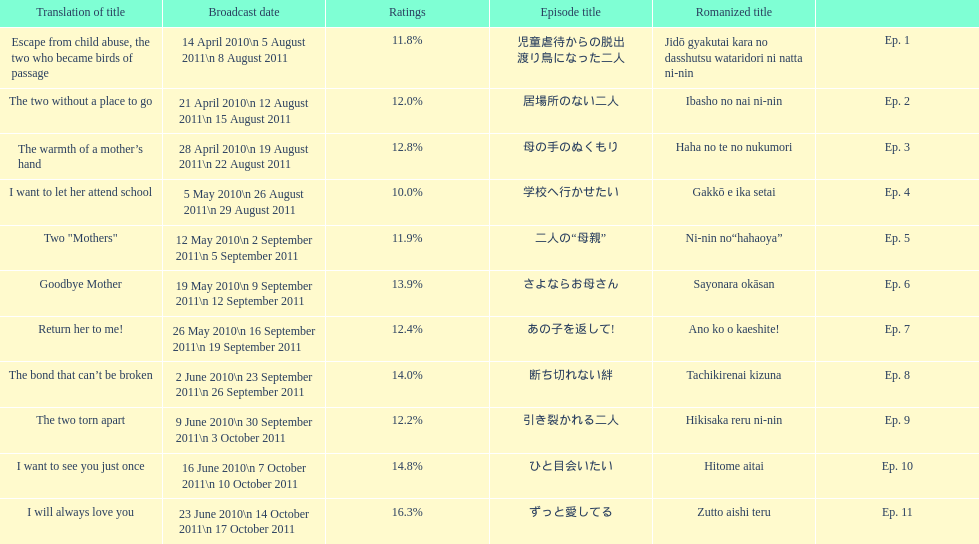What was the title of the episode that followed "goodbye mother"? あの子を返して!. 